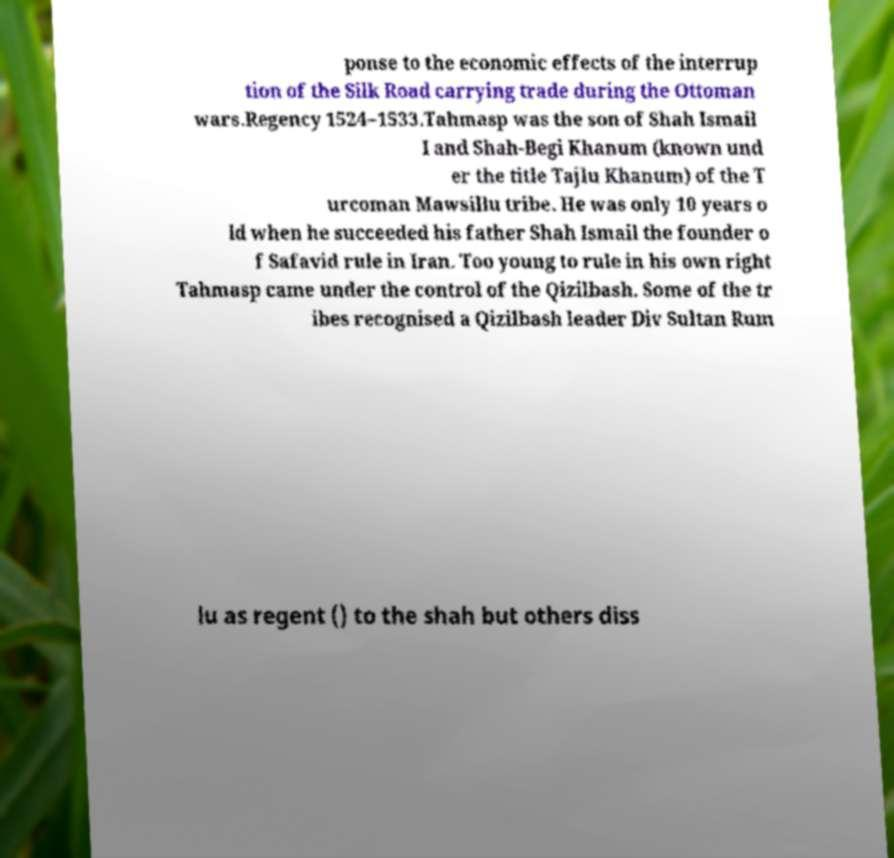Could you extract and type out the text from this image? ponse to the economic effects of the interrup tion of the Silk Road carrying trade during the Ottoman wars.Regency 1524–1533.Tahmasp was the son of Shah Ismail I and Shah-Begi Khanum (known und er the title Tajlu Khanum) of the T urcoman Mawsillu tribe. He was only 10 years o ld when he succeeded his father Shah Ismail the founder o f Safavid rule in Iran. Too young to rule in his own right Tahmasp came under the control of the Qizilbash. Some of the tr ibes recognised a Qizilbash leader Div Sultan Rum lu as regent () to the shah but others diss 